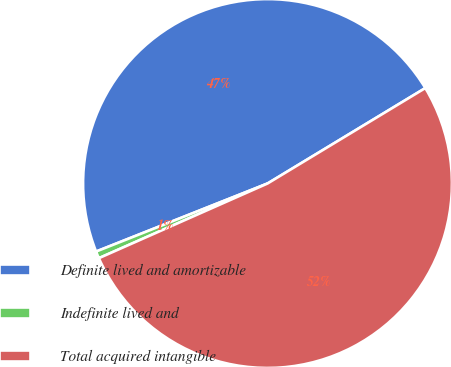Convert chart to OTSL. <chart><loc_0><loc_0><loc_500><loc_500><pie_chart><fcel>Definite lived and amortizable<fcel>Indefinite lived and<fcel>Total acquired intangible<nl><fcel>47.35%<fcel>0.62%<fcel>52.02%<nl></chart> 